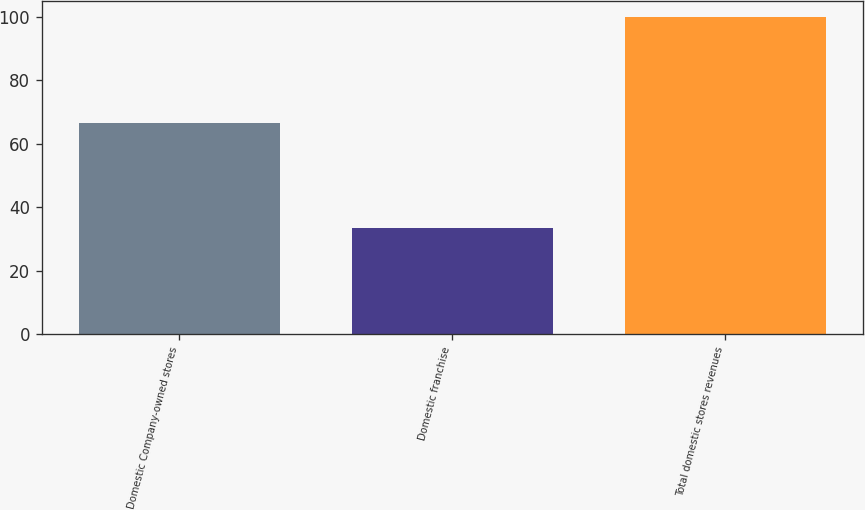Convert chart. <chart><loc_0><loc_0><loc_500><loc_500><bar_chart><fcel>Domestic Company-owned stores<fcel>Domestic franchise<fcel>Total domestic stores revenues<nl><fcel>66.6<fcel>33.4<fcel>100<nl></chart> 